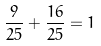Convert formula to latex. <formula><loc_0><loc_0><loc_500><loc_500>\frac { 9 } { 2 5 } + \frac { 1 6 } { 2 5 } = 1</formula> 